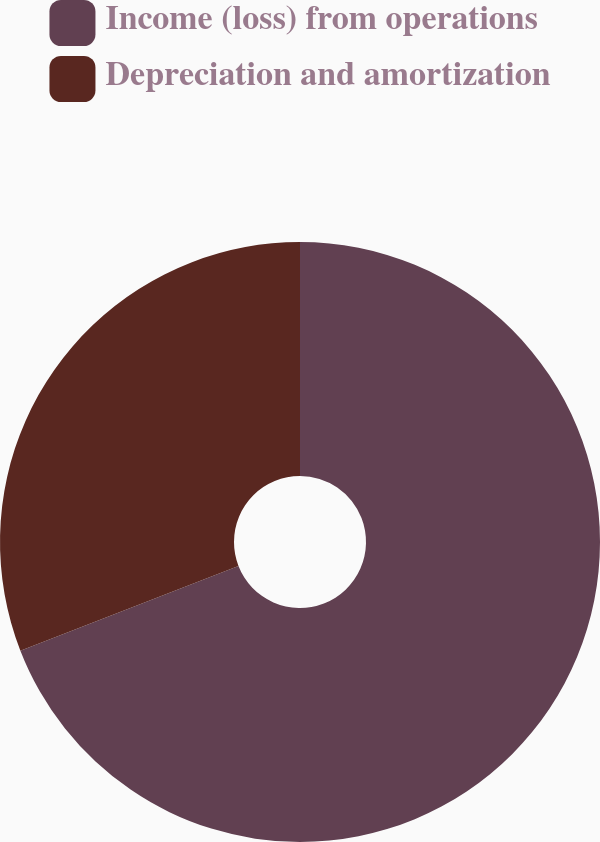Convert chart to OTSL. <chart><loc_0><loc_0><loc_500><loc_500><pie_chart><fcel>Income (loss) from operations<fcel>Depreciation and amortization<nl><fcel>69.1%<fcel>30.9%<nl></chart> 